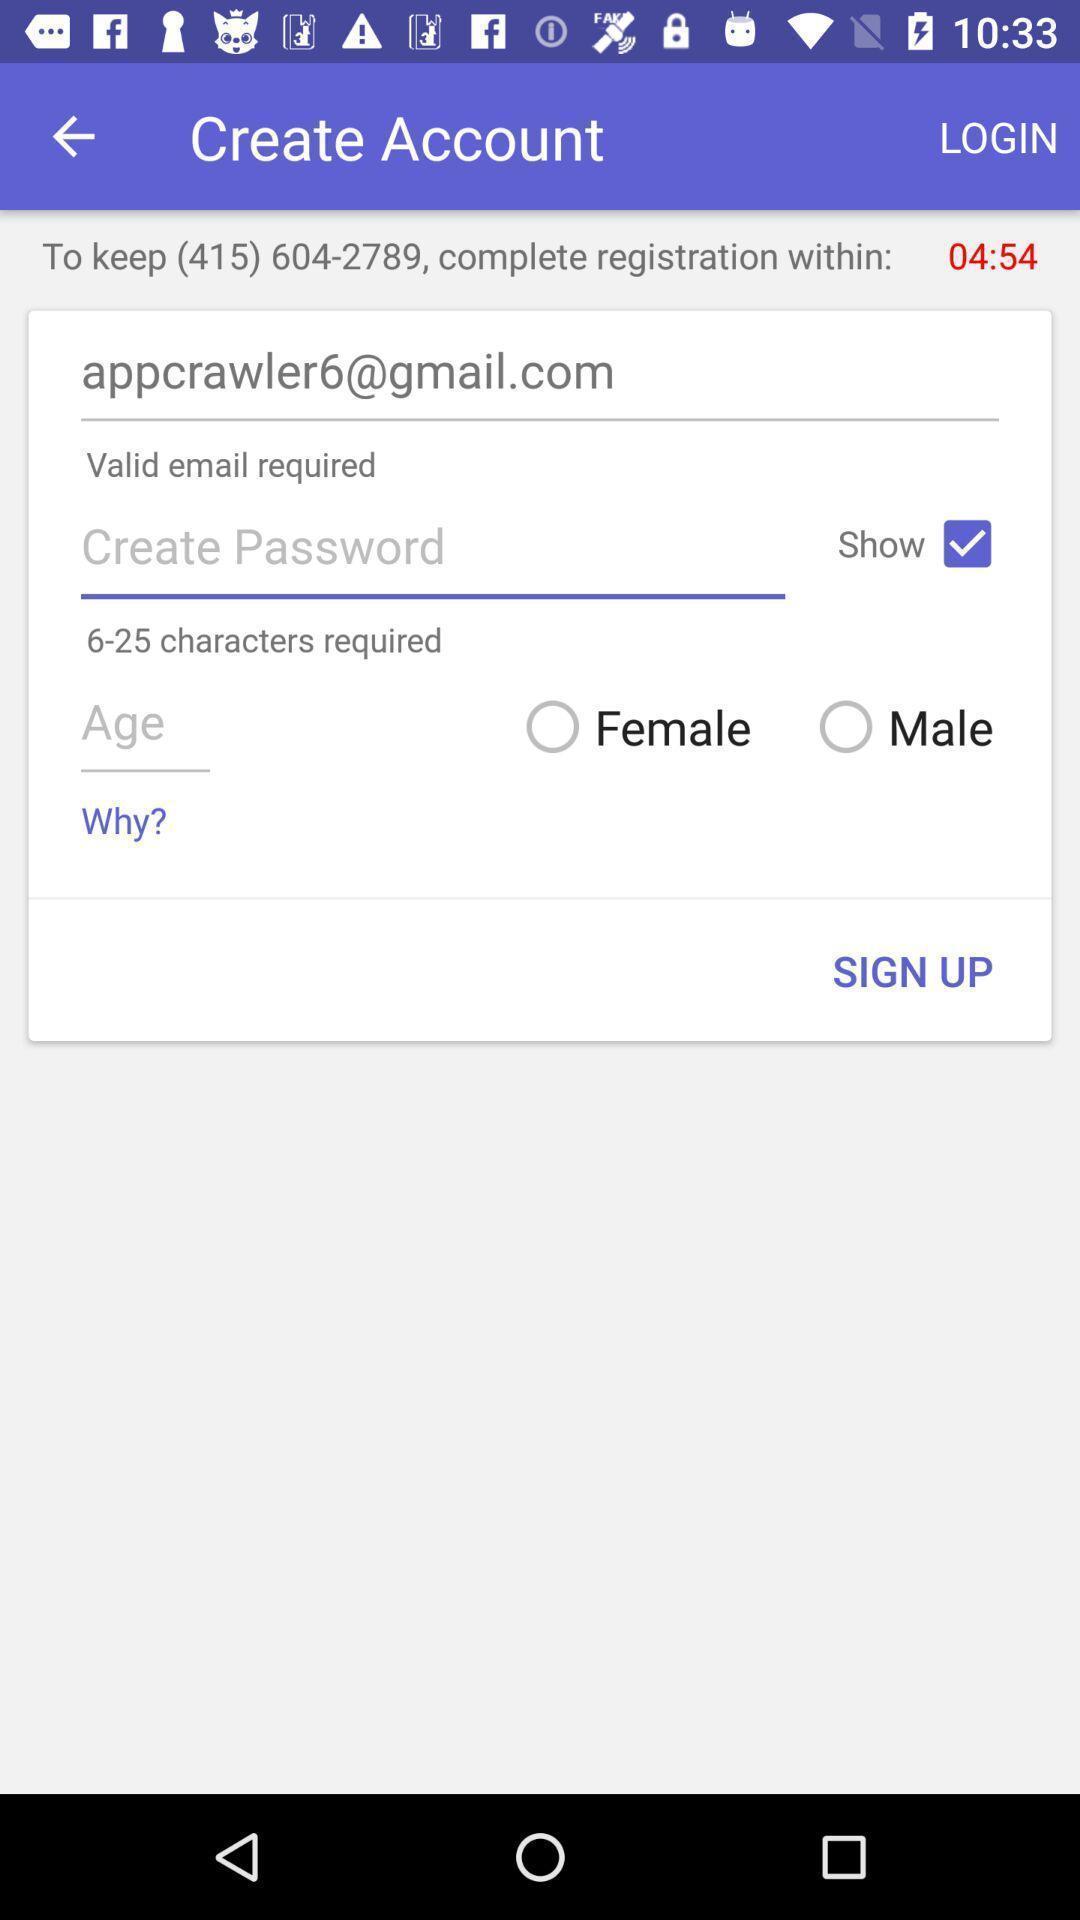Provide a textual representation of this image. Sign-up page to create an account. 